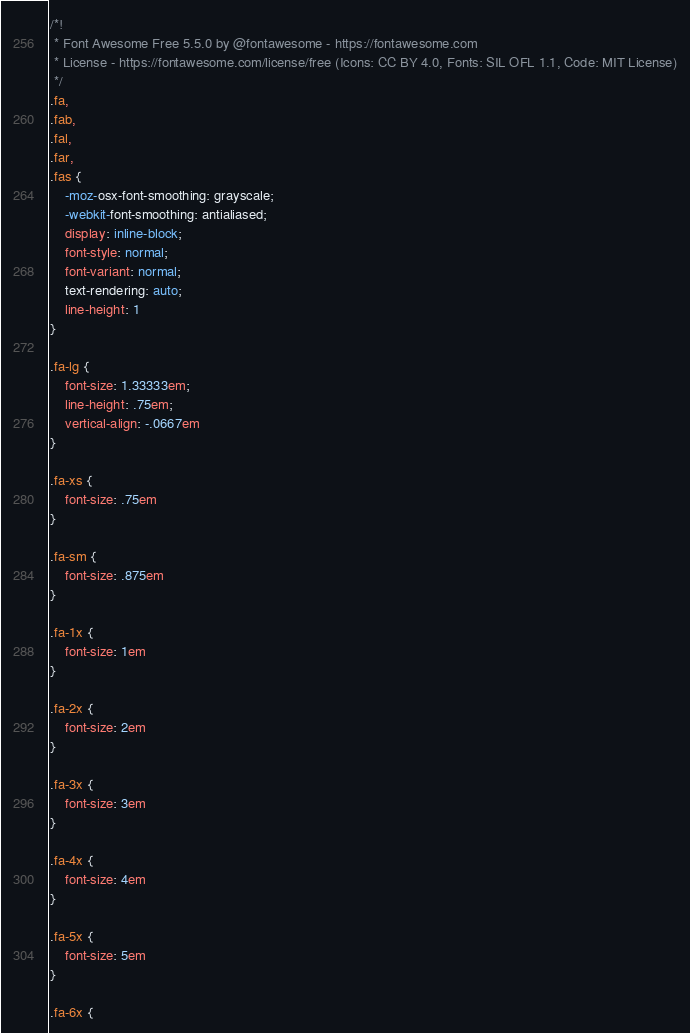<code> <loc_0><loc_0><loc_500><loc_500><_CSS_>/*!
 * Font Awesome Free 5.5.0 by @fontawesome - https://fontawesome.com
 * License - https://fontawesome.com/license/free (Icons: CC BY 4.0, Fonts: SIL OFL 1.1, Code: MIT License)
 */
.fa,
.fab,
.fal,
.far,
.fas {
    -moz-osx-font-smoothing: grayscale;
    -webkit-font-smoothing: antialiased;
    display: inline-block;
    font-style: normal;
    font-variant: normal;
    text-rendering: auto;
    line-height: 1
}

.fa-lg {
    font-size: 1.33333em;
    line-height: .75em;
    vertical-align: -.0667em
}

.fa-xs {
    font-size: .75em
}

.fa-sm {
    font-size: .875em
}

.fa-1x {
    font-size: 1em
}

.fa-2x {
    font-size: 2em
}

.fa-3x {
    font-size: 3em
}

.fa-4x {
    font-size: 4em
}

.fa-5x {
    font-size: 5em
}

.fa-6x {</code> 